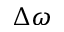Convert formula to latex. <formula><loc_0><loc_0><loc_500><loc_500>\Delta \omega</formula> 